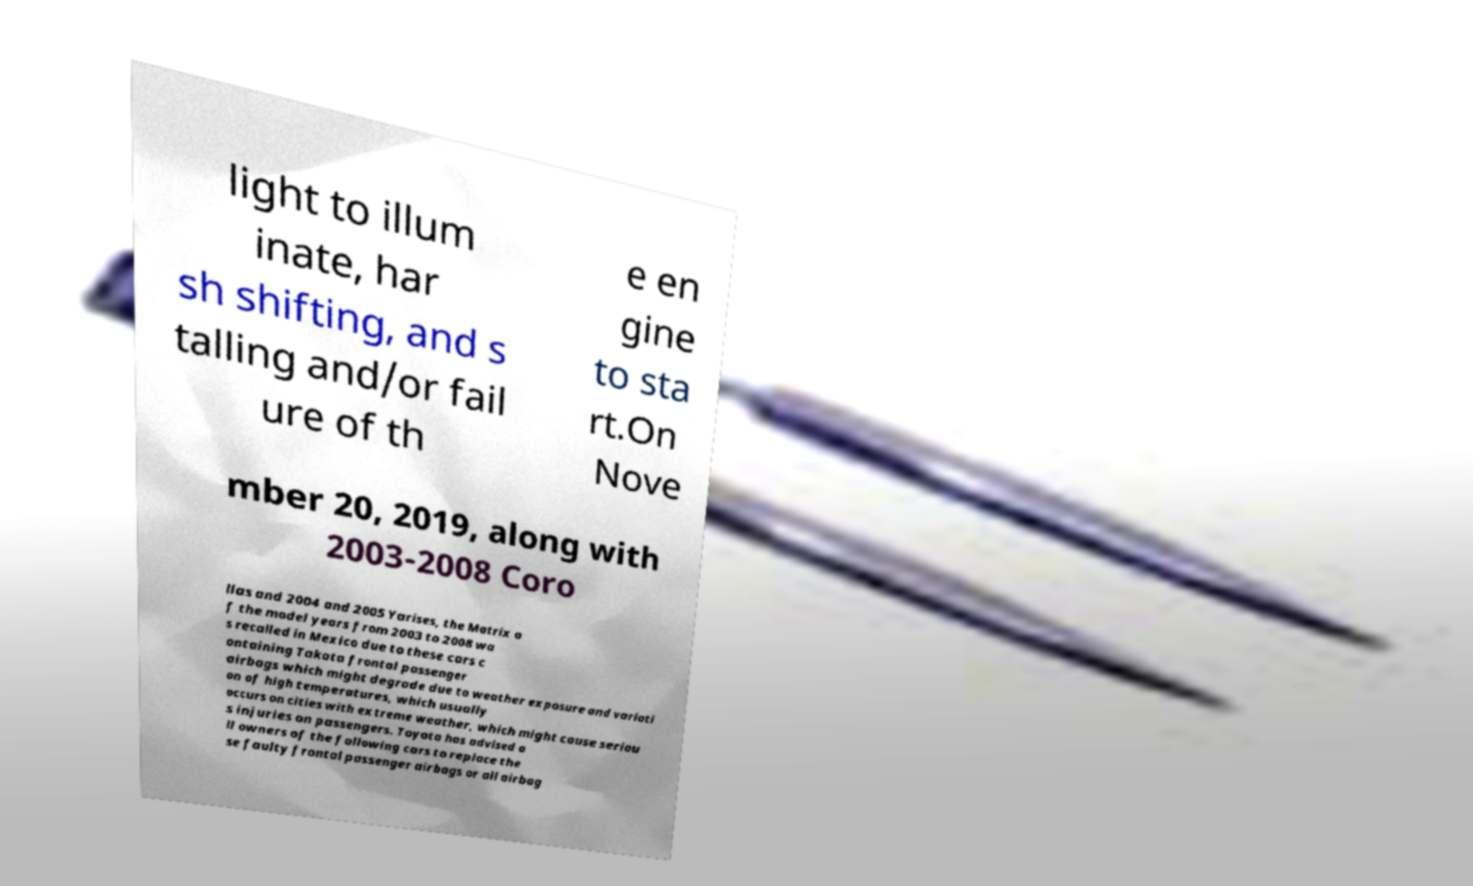Can you accurately transcribe the text from the provided image for me? light to illum inate, har sh shifting, and s talling and/or fail ure of th e en gine to sta rt.On Nove mber 20, 2019, along with 2003-2008 Coro llas and 2004 and 2005 Yarises, the Matrix o f the model years from 2003 to 2008 wa s recalled in Mexico due to these cars c ontaining Takata frontal passenger airbags which might degrade due to weather exposure and variati on of high temperatures, which usually occurs on cities with extreme weather, which might cause seriou s injuries on passengers. Toyota has advised a ll owners of the following cars to replace the se faulty frontal passenger airbags or all airbag 